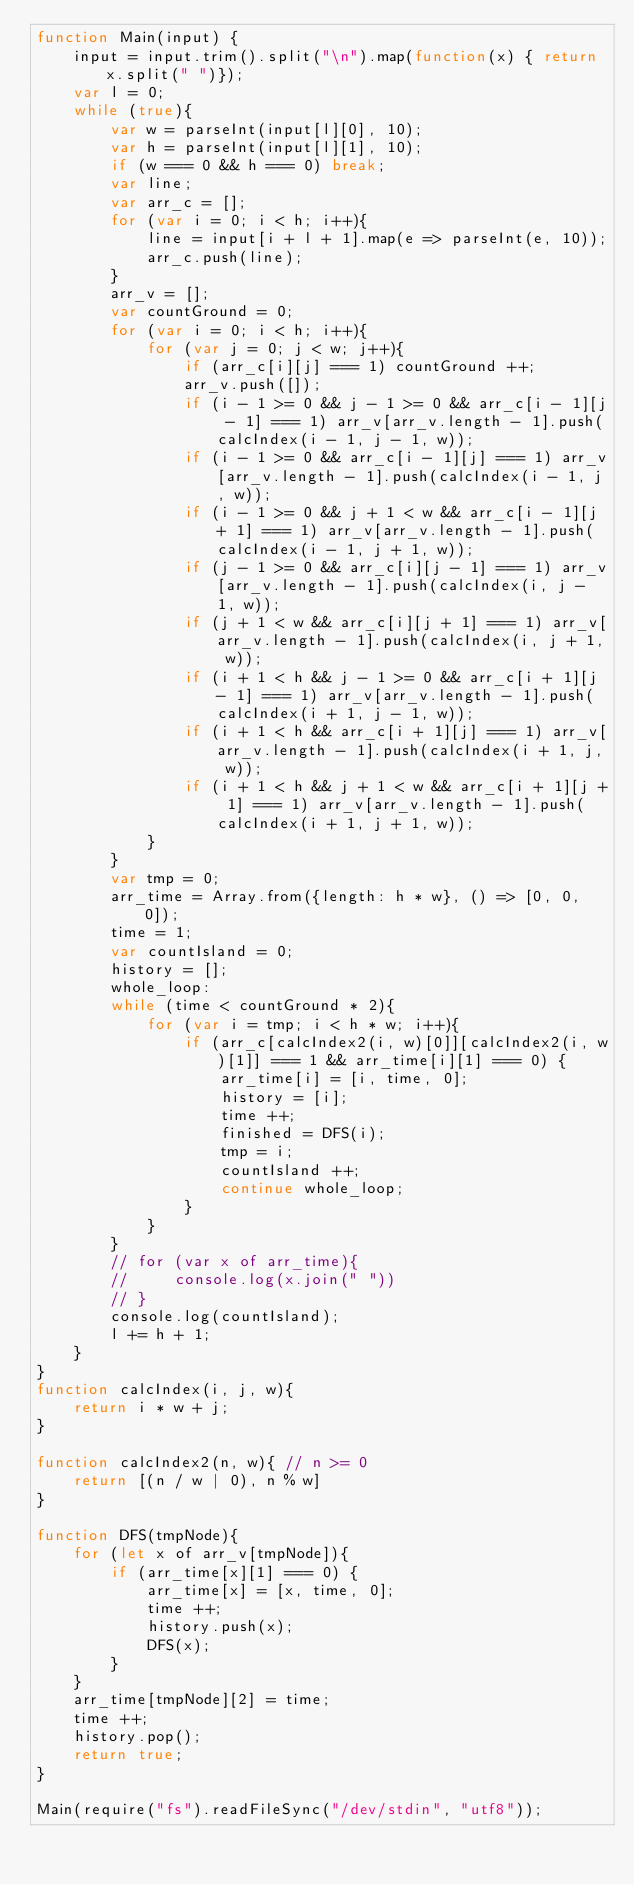Convert code to text. <code><loc_0><loc_0><loc_500><loc_500><_JavaScript_>function Main(input) {
    input = input.trim().split("\n").map(function(x) { return x.split(" ")});
    var l = 0;
    while (true){
        var w = parseInt(input[l][0], 10);
        var h = parseInt(input[l][1], 10);
        if (w === 0 && h === 0) break;
        var line;
        var arr_c = [];
        for (var i = 0; i < h; i++){
            line = input[i + l + 1].map(e => parseInt(e, 10));
            arr_c.push(line);
        }
        arr_v = [];
        var countGround = 0;
        for (var i = 0; i < h; i++){
            for (var j = 0; j < w; j++){
                if (arr_c[i][j] === 1) countGround ++;
                arr_v.push([]);
                if (i - 1 >= 0 && j - 1 >= 0 && arr_c[i - 1][j - 1] === 1) arr_v[arr_v.length - 1].push(calcIndex(i - 1, j - 1, w));
                if (i - 1 >= 0 && arr_c[i - 1][j] === 1) arr_v[arr_v.length - 1].push(calcIndex(i - 1, j, w));
                if (i - 1 >= 0 && j + 1 < w && arr_c[i - 1][j + 1] === 1) arr_v[arr_v.length - 1].push(calcIndex(i - 1, j + 1, w));
                if (j - 1 >= 0 && arr_c[i][j - 1] === 1) arr_v[arr_v.length - 1].push(calcIndex(i, j - 1, w));
                if (j + 1 < w && arr_c[i][j + 1] === 1) arr_v[arr_v.length - 1].push(calcIndex(i, j + 1, w));
                if (i + 1 < h && j - 1 >= 0 && arr_c[i + 1][j - 1] === 1) arr_v[arr_v.length - 1].push(calcIndex(i + 1, j - 1, w));
                if (i + 1 < h && arr_c[i + 1][j] === 1) arr_v[arr_v.length - 1].push(calcIndex(i + 1, j, w));
                if (i + 1 < h && j + 1 < w && arr_c[i + 1][j + 1] === 1) arr_v[arr_v.length - 1].push(calcIndex(i + 1, j + 1, w));
            }
        }
        var tmp = 0;
        arr_time = Array.from({length: h * w}, () => [0, 0, 0]);
        time = 1;
        var countIsland = 0;
        history = [];
        whole_loop:
        while (time < countGround * 2){
            for (var i = tmp; i < h * w; i++){
                if (arr_c[calcIndex2(i, w)[0]][calcIndex2(i, w)[1]] === 1 && arr_time[i][1] === 0) {
                    arr_time[i] = [i, time, 0];
                    history = [i];
                    time ++;
                    finished = DFS(i);
                    tmp = i;
                    countIsland ++;
                    continue whole_loop;
                }
            }
        }
        // for (var x of arr_time){
        //     console.log(x.join(" "))
        // }
        console.log(countIsland);
        l += h + 1;
    }
}
function calcIndex(i, j, w){
    return i * w + j;
}

function calcIndex2(n, w){ // n >= 0
    return [(n / w | 0), n % w]
}

function DFS(tmpNode){
    for (let x of arr_v[tmpNode]){
        if (arr_time[x][1] === 0) {
            arr_time[x] = [x, time, 0];
            time ++;
            history.push(x);
            DFS(x);
        } 
    }
    arr_time[tmpNode][2] = time;
    time ++;
    history.pop();
    return true;
}

Main(require("fs").readFileSync("/dev/stdin", "utf8")); 


</code> 